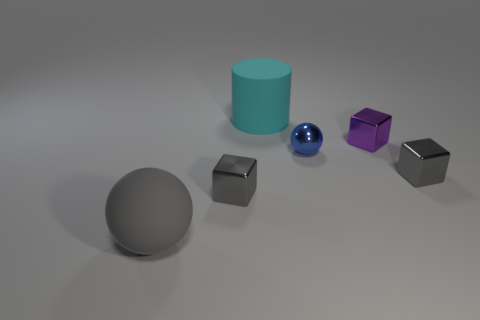Add 4 gray metal blocks. How many objects exist? 10 Subtract all cylinders. How many objects are left? 5 Subtract 0 blue cubes. How many objects are left? 6 Subtract all small cyan shiny cylinders. Subtract all small shiny cubes. How many objects are left? 3 Add 1 rubber cylinders. How many rubber cylinders are left? 2 Add 6 big cyan matte cylinders. How many big cyan matte cylinders exist? 7 